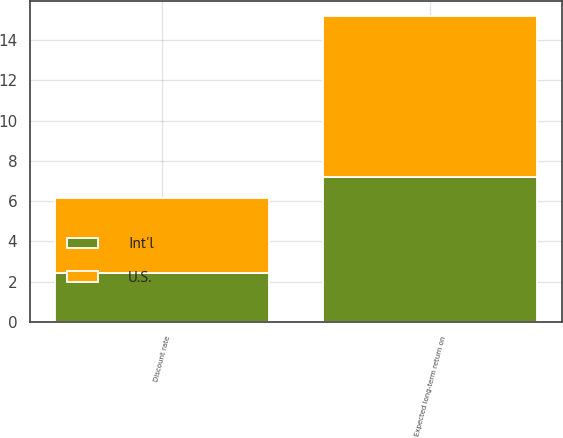<chart> <loc_0><loc_0><loc_500><loc_500><stacked_bar_chart><ecel><fcel>Discount rate<fcel>Expected long-term return on<nl><fcel>U.S.<fcel>3.75<fcel>8<nl><fcel>Int'l<fcel>2.43<fcel>7.2<nl></chart> 